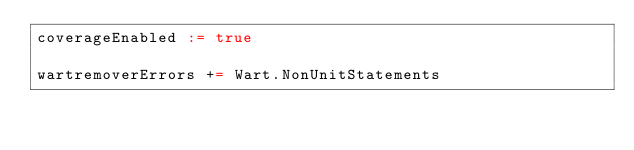Convert code to text. <code><loc_0><loc_0><loc_500><loc_500><_Scala_>coverageEnabled := true

wartremoverErrors += Wart.NonUnitStatements
</code> 